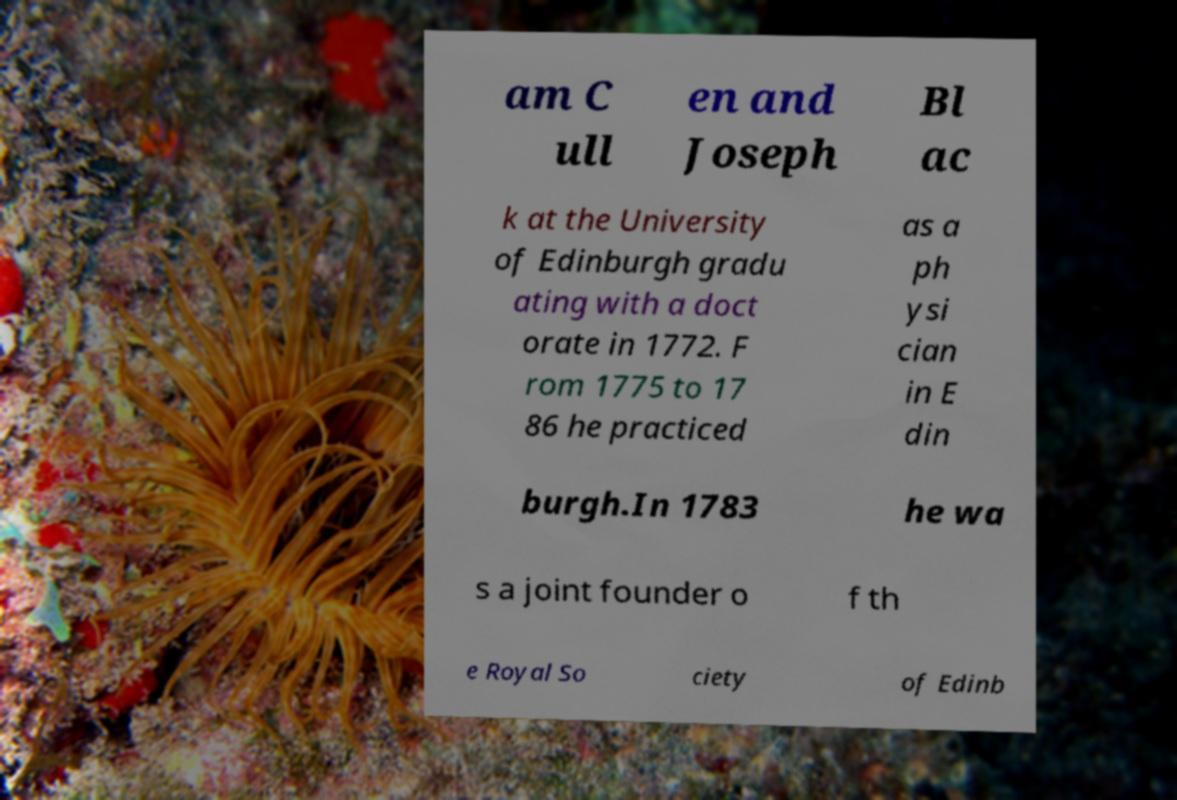I need the written content from this picture converted into text. Can you do that? am C ull en and Joseph Bl ac k at the University of Edinburgh gradu ating with a doct orate in 1772. F rom 1775 to 17 86 he practiced as a ph ysi cian in E din burgh.In 1783 he wa s a joint founder o f th e Royal So ciety of Edinb 